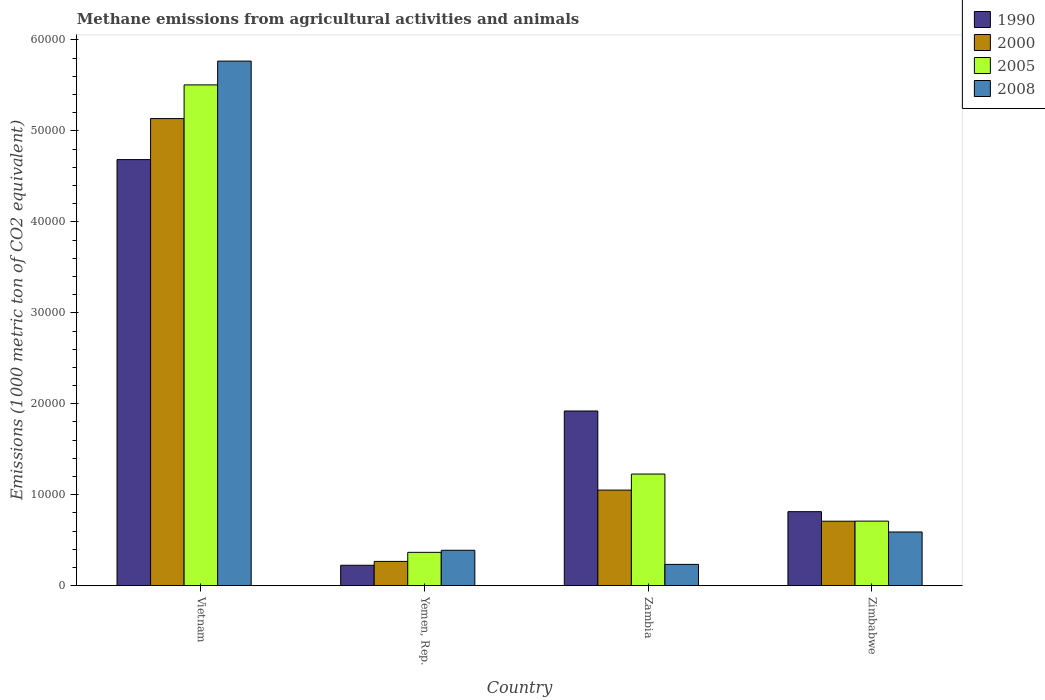How many groups of bars are there?
Make the answer very short. 4. Are the number of bars on each tick of the X-axis equal?
Offer a very short reply. Yes. How many bars are there on the 2nd tick from the right?
Offer a very short reply. 4. What is the label of the 4th group of bars from the left?
Make the answer very short. Zimbabwe. What is the amount of methane emitted in 2005 in Vietnam?
Give a very brief answer. 5.51e+04. Across all countries, what is the maximum amount of methane emitted in 2000?
Offer a terse response. 5.14e+04. Across all countries, what is the minimum amount of methane emitted in 1990?
Give a very brief answer. 2246.7. In which country was the amount of methane emitted in 2008 maximum?
Make the answer very short. Vietnam. In which country was the amount of methane emitted in 1990 minimum?
Offer a very short reply. Yemen, Rep. What is the total amount of methane emitted in 1990 in the graph?
Your response must be concise. 7.64e+04. What is the difference between the amount of methane emitted in 2000 in Vietnam and that in Zimbabwe?
Your answer should be compact. 4.43e+04. What is the difference between the amount of methane emitted in 2000 in Yemen, Rep. and the amount of methane emitted in 1990 in Vietnam?
Provide a succinct answer. -4.42e+04. What is the average amount of methane emitted in 2008 per country?
Give a very brief answer. 1.75e+04. What is the difference between the amount of methane emitted of/in 2000 and amount of methane emitted of/in 2005 in Zimbabwe?
Make the answer very short. -9.1. In how many countries, is the amount of methane emitted in 1990 greater than 12000 1000 metric ton?
Offer a terse response. 2. What is the ratio of the amount of methane emitted in 2000 in Vietnam to that in Zambia?
Your answer should be very brief. 4.89. What is the difference between the highest and the second highest amount of methane emitted in 2005?
Provide a succinct answer. -5176.1. What is the difference between the highest and the lowest amount of methane emitted in 1990?
Offer a very short reply. 4.46e+04. Is it the case that in every country, the sum of the amount of methane emitted in 1990 and amount of methane emitted in 2005 is greater than the sum of amount of methane emitted in 2000 and amount of methane emitted in 2008?
Give a very brief answer. No. What does the 3rd bar from the left in Zimbabwe represents?
Provide a succinct answer. 2005. What does the 2nd bar from the right in Zambia represents?
Ensure brevity in your answer.  2005. How many bars are there?
Your response must be concise. 16. Does the graph contain grids?
Your answer should be very brief. No. Where does the legend appear in the graph?
Provide a succinct answer. Top right. What is the title of the graph?
Your answer should be very brief. Methane emissions from agricultural activities and animals. Does "1975" appear as one of the legend labels in the graph?
Your answer should be very brief. No. What is the label or title of the Y-axis?
Ensure brevity in your answer.  Emissions (1000 metric ton of CO2 equivalent). What is the Emissions (1000 metric ton of CO2 equivalent) in 1990 in Vietnam?
Ensure brevity in your answer.  4.68e+04. What is the Emissions (1000 metric ton of CO2 equivalent) in 2000 in Vietnam?
Give a very brief answer. 5.14e+04. What is the Emissions (1000 metric ton of CO2 equivalent) in 2005 in Vietnam?
Your response must be concise. 5.51e+04. What is the Emissions (1000 metric ton of CO2 equivalent) of 2008 in Vietnam?
Ensure brevity in your answer.  5.77e+04. What is the Emissions (1000 metric ton of CO2 equivalent) of 1990 in Yemen, Rep.?
Provide a short and direct response. 2246.7. What is the Emissions (1000 metric ton of CO2 equivalent) of 2000 in Yemen, Rep.?
Make the answer very short. 2671. What is the Emissions (1000 metric ton of CO2 equivalent) in 2005 in Yemen, Rep.?
Your response must be concise. 3666.5. What is the Emissions (1000 metric ton of CO2 equivalent) in 2008 in Yemen, Rep.?
Your answer should be very brief. 3893.6. What is the Emissions (1000 metric ton of CO2 equivalent) of 1990 in Zambia?
Ensure brevity in your answer.  1.92e+04. What is the Emissions (1000 metric ton of CO2 equivalent) in 2000 in Zambia?
Keep it short and to the point. 1.05e+04. What is the Emissions (1000 metric ton of CO2 equivalent) of 2005 in Zambia?
Provide a short and direct response. 1.23e+04. What is the Emissions (1000 metric ton of CO2 equivalent) in 2008 in Zambia?
Offer a very short reply. 2342.5. What is the Emissions (1000 metric ton of CO2 equivalent) in 1990 in Zimbabwe?
Your answer should be very brief. 8138.9. What is the Emissions (1000 metric ton of CO2 equivalent) of 2000 in Zimbabwe?
Your response must be concise. 7089.3. What is the Emissions (1000 metric ton of CO2 equivalent) of 2005 in Zimbabwe?
Ensure brevity in your answer.  7098.4. What is the Emissions (1000 metric ton of CO2 equivalent) of 2008 in Zimbabwe?
Offer a very short reply. 5904.5. Across all countries, what is the maximum Emissions (1000 metric ton of CO2 equivalent) in 1990?
Provide a succinct answer. 4.68e+04. Across all countries, what is the maximum Emissions (1000 metric ton of CO2 equivalent) of 2000?
Provide a succinct answer. 5.14e+04. Across all countries, what is the maximum Emissions (1000 metric ton of CO2 equivalent) in 2005?
Your answer should be very brief. 5.51e+04. Across all countries, what is the maximum Emissions (1000 metric ton of CO2 equivalent) of 2008?
Make the answer very short. 5.77e+04. Across all countries, what is the minimum Emissions (1000 metric ton of CO2 equivalent) of 1990?
Provide a succinct answer. 2246.7. Across all countries, what is the minimum Emissions (1000 metric ton of CO2 equivalent) of 2000?
Provide a short and direct response. 2671. Across all countries, what is the minimum Emissions (1000 metric ton of CO2 equivalent) in 2005?
Offer a very short reply. 3666.5. Across all countries, what is the minimum Emissions (1000 metric ton of CO2 equivalent) of 2008?
Provide a succinct answer. 2342.5. What is the total Emissions (1000 metric ton of CO2 equivalent) of 1990 in the graph?
Provide a succinct answer. 7.64e+04. What is the total Emissions (1000 metric ton of CO2 equivalent) in 2000 in the graph?
Keep it short and to the point. 7.16e+04. What is the total Emissions (1000 metric ton of CO2 equivalent) in 2005 in the graph?
Your response must be concise. 7.81e+04. What is the total Emissions (1000 metric ton of CO2 equivalent) in 2008 in the graph?
Your answer should be very brief. 6.98e+04. What is the difference between the Emissions (1000 metric ton of CO2 equivalent) of 1990 in Vietnam and that in Yemen, Rep.?
Make the answer very short. 4.46e+04. What is the difference between the Emissions (1000 metric ton of CO2 equivalent) of 2000 in Vietnam and that in Yemen, Rep.?
Keep it short and to the point. 4.87e+04. What is the difference between the Emissions (1000 metric ton of CO2 equivalent) in 2005 in Vietnam and that in Yemen, Rep.?
Make the answer very short. 5.14e+04. What is the difference between the Emissions (1000 metric ton of CO2 equivalent) of 2008 in Vietnam and that in Yemen, Rep.?
Ensure brevity in your answer.  5.38e+04. What is the difference between the Emissions (1000 metric ton of CO2 equivalent) in 1990 in Vietnam and that in Zambia?
Make the answer very short. 2.76e+04. What is the difference between the Emissions (1000 metric ton of CO2 equivalent) of 2000 in Vietnam and that in Zambia?
Provide a short and direct response. 4.08e+04. What is the difference between the Emissions (1000 metric ton of CO2 equivalent) of 2005 in Vietnam and that in Zambia?
Your answer should be compact. 4.28e+04. What is the difference between the Emissions (1000 metric ton of CO2 equivalent) of 2008 in Vietnam and that in Zambia?
Ensure brevity in your answer.  5.53e+04. What is the difference between the Emissions (1000 metric ton of CO2 equivalent) in 1990 in Vietnam and that in Zimbabwe?
Your response must be concise. 3.87e+04. What is the difference between the Emissions (1000 metric ton of CO2 equivalent) in 2000 in Vietnam and that in Zimbabwe?
Make the answer very short. 4.43e+04. What is the difference between the Emissions (1000 metric ton of CO2 equivalent) in 2005 in Vietnam and that in Zimbabwe?
Keep it short and to the point. 4.80e+04. What is the difference between the Emissions (1000 metric ton of CO2 equivalent) in 2008 in Vietnam and that in Zimbabwe?
Your answer should be compact. 5.18e+04. What is the difference between the Emissions (1000 metric ton of CO2 equivalent) of 1990 in Yemen, Rep. and that in Zambia?
Provide a succinct answer. -1.70e+04. What is the difference between the Emissions (1000 metric ton of CO2 equivalent) of 2000 in Yemen, Rep. and that in Zambia?
Offer a terse response. -7837.9. What is the difference between the Emissions (1000 metric ton of CO2 equivalent) in 2005 in Yemen, Rep. and that in Zambia?
Your response must be concise. -8608. What is the difference between the Emissions (1000 metric ton of CO2 equivalent) of 2008 in Yemen, Rep. and that in Zambia?
Your response must be concise. 1551.1. What is the difference between the Emissions (1000 metric ton of CO2 equivalent) in 1990 in Yemen, Rep. and that in Zimbabwe?
Provide a succinct answer. -5892.2. What is the difference between the Emissions (1000 metric ton of CO2 equivalent) of 2000 in Yemen, Rep. and that in Zimbabwe?
Keep it short and to the point. -4418.3. What is the difference between the Emissions (1000 metric ton of CO2 equivalent) of 2005 in Yemen, Rep. and that in Zimbabwe?
Ensure brevity in your answer.  -3431.9. What is the difference between the Emissions (1000 metric ton of CO2 equivalent) of 2008 in Yemen, Rep. and that in Zimbabwe?
Provide a short and direct response. -2010.9. What is the difference between the Emissions (1000 metric ton of CO2 equivalent) of 1990 in Zambia and that in Zimbabwe?
Ensure brevity in your answer.  1.11e+04. What is the difference between the Emissions (1000 metric ton of CO2 equivalent) in 2000 in Zambia and that in Zimbabwe?
Your answer should be compact. 3419.6. What is the difference between the Emissions (1000 metric ton of CO2 equivalent) of 2005 in Zambia and that in Zimbabwe?
Make the answer very short. 5176.1. What is the difference between the Emissions (1000 metric ton of CO2 equivalent) in 2008 in Zambia and that in Zimbabwe?
Keep it short and to the point. -3562. What is the difference between the Emissions (1000 metric ton of CO2 equivalent) of 1990 in Vietnam and the Emissions (1000 metric ton of CO2 equivalent) of 2000 in Yemen, Rep.?
Make the answer very short. 4.42e+04. What is the difference between the Emissions (1000 metric ton of CO2 equivalent) of 1990 in Vietnam and the Emissions (1000 metric ton of CO2 equivalent) of 2005 in Yemen, Rep.?
Your answer should be compact. 4.32e+04. What is the difference between the Emissions (1000 metric ton of CO2 equivalent) in 1990 in Vietnam and the Emissions (1000 metric ton of CO2 equivalent) in 2008 in Yemen, Rep.?
Keep it short and to the point. 4.30e+04. What is the difference between the Emissions (1000 metric ton of CO2 equivalent) in 2000 in Vietnam and the Emissions (1000 metric ton of CO2 equivalent) in 2005 in Yemen, Rep.?
Provide a short and direct response. 4.77e+04. What is the difference between the Emissions (1000 metric ton of CO2 equivalent) of 2000 in Vietnam and the Emissions (1000 metric ton of CO2 equivalent) of 2008 in Yemen, Rep.?
Give a very brief answer. 4.75e+04. What is the difference between the Emissions (1000 metric ton of CO2 equivalent) of 2005 in Vietnam and the Emissions (1000 metric ton of CO2 equivalent) of 2008 in Yemen, Rep.?
Your answer should be compact. 5.12e+04. What is the difference between the Emissions (1000 metric ton of CO2 equivalent) in 1990 in Vietnam and the Emissions (1000 metric ton of CO2 equivalent) in 2000 in Zambia?
Your answer should be compact. 3.63e+04. What is the difference between the Emissions (1000 metric ton of CO2 equivalent) of 1990 in Vietnam and the Emissions (1000 metric ton of CO2 equivalent) of 2005 in Zambia?
Keep it short and to the point. 3.46e+04. What is the difference between the Emissions (1000 metric ton of CO2 equivalent) of 1990 in Vietnam and the Emissions (1000 metric ton of CO2 equivalent) of 2008 in Zambia?
Your answer should be very brief. 4.45e+04. What is the difference between the Emissions (1000 metric ton of CO2 equivalent) in 2000 in Vietnam and the Emissions (1000 metric ton of CO2 equivalent) in 2005 in Zambia?
Give a very brief answer. 3.91e+04. What is the difference between the Emissions (1000 metric ton of CO2 equivalent) in 2000 in Vietnam and the Emissions (1000 metric ton of CO2 equivalent) in 2008 in Zambia?
Offer a very short reply. 4.90e+04. What is the difference between the Emissions (1000 metric ton of CO2 equivalent) in 2005 in Vietnam and the Emissions (1000 metric ton of CO2 equivalent) in 2008 in Zambia?
Provide a succinct answer. 5.27e+04. What is the difference between the Emissions (1000 metric ton of CO2 equivalent) of 1990 in Vietnam and the Emissions (1000 metric ton of CO2 equivalent) of 2000 in Zimbabwe?
Your answer should be compact. 3.98e+04. What is the difference between the Emissions (1000 metric ton of CO2 equivalent) in 1990 in Vietnam and the Emissions (1000 metric ton of CO2 equivalent) in 2005 in Zimbabwe?
Your response must be concise. 3.97e+04. What is the difference between the Emissions (1000 metric ton of CO2 equivalent) of 1990 in Vietnam and the Emissions (1000 metric ton of CO2 equivalent) of 2008 in Zimbabwe?
Ensure brevity in your answer.  4.09e+04. What is the difference between the Emissions (1000 metric ton of CO2 equivalent) in 2000 in Vietnam and the Emissions (1000 metric ton of CO2 equivalent) in 2005 in Zimbabwe?
Your answer should be very brief. 4.43e+04. What is the difference between the Emissions (1000 metric ton of CO2 equivalent) in 2000 in Vietnam and the Emissions (1000 metric ton of CO2 equivalent) in 2008 in Zimbabwe?
Give a very brief answer. 4.55e+04. What is the difference between the Emissions (1000 metric ton of CO2 equivalent) of 2005 in Vietnam and the Emissions (1000 metric ton of CO2 equivalent) of 2008 in Zimbabwe?
Keep it short and to the point. 4.92e+04. What is the difference between the Emissions (1000 metric ton of CO2 equivalent) in 1990 in Yemen, Rep. and the Emissions (1000 metric ton of CO2 equivalent) in 2000 in Zambia?
Keep it short and to the point. -8262.2. What is the difference between the Emissions (1000 metric ton of CO2 equivalent) in 1990 in Yemen, Rep. and the Emissions (1000 metric ton of CO2 equivalent) in 2005 in Zambia?
Offer a terse response. -1.00e+04. What is the difference between the Emissions (1000 metric ton of CO2 equivalent) in 1990 in Yemen, Rep. and the Emissions (1000 metric ton of CO2 equivalent) in 2008 in Zambia?
Offer a terse response. -95.8. What is the difference between the Emissions (1000 metric ton of CO2 equivalent) of 2000 in Yemen, Rep. and the Emissions (1000 metric ton of CO2 equivalent) of 2005 in Zambia?
Offer a terse response. -9603.5. What is the difference between the Emissions (1000 metric ton of CO2 equivalent) in 2000 in Yemen, Rep. and the Emissions (1000 metric ton of CO2 equivalent) in 2008 in Zambia?
Give a very brief answer. 328.5. What is the difference between the Emissions (1000 metric ton of CO2 equivalent) of 2005 in Yemen, Rep. and the Emissions (1000 metric ton of CO2 equivalent) of 2008 in Zambia?
Make the answer very short. 1324. What is the difference between the Emissions (1000 metric ton of CO2 equivalent) in 1990 in Yemen, Rep. and the Emissions (1000 metric ton of CO2 equivalent) in 2000 in Zimbabwe?
Offer a terse response. -4842.6. What is the difference between the Emissions (1000 metric ton of CO2 equivalent) in 1990 in Yemen, Rep. and the Emissions (1000 metric ton of CO2 equivalent) in 2005 in Zimbabwe?
Provide a short and direct response. -4851.7. What is the difference between the Emissions (1000 metric ton of CO2 equivalent) in 1990 in Yemen, Rep. and the Emissions (1000 metric ton of CO2 equivalent) in 2008 in Zimbabwe?
Ensure brevity in your answer.  -3657.8. What is the difference between the Emissions (1000 metric ton of CO2 equivalent) in 2000 in Yemen, Rep. and the Emissions (1000 metric ton of CO2 equivalent) in 2005 in Zimbabwe?
Give a very brief answer. -4427.4. What is the difference between the Emissions (1000 metric ton of CO2 equivalent) in 2000 in Yemen, Rep. and the Emissions (1000 metric ton of CO2 equivalent) in 2008 in Zimbabwe?
Provide a short and direct response. -3233.5. What is the difference between the Emissions (1000 metric ton of CO2 equivalent) of 2005 in Yemen, Rep. and the Emissions (1000 metric ton of CO2 equivalent) of 2008 in Zimbabwe?
Your answer should be very brief. -2238. What is the difference between the Emissions (1000 metric ton of CO2 equivalent) in 1990 in Zambia and the Emissions (1000 metric ton of CO2 equivalent) in 2000 in Zimbabwe?
Your answer should be compact. 1.21e+04. What is the difference between the Emissions (1000 metric ton of CO2 equivalent) of 1990 in Zambia and the Emissions (1000 metric ton of CO2 equivalent) of 2005 in Zimbabwe?
Your answer should be very brief. 1.21e+04. What is the difference between the Emissions (1000 metric ton of CO2 equivalent) of 1990 in Zambia and the Emissions (1000 metric ton of CO2 equivalent) of 2008 in Zimbabwe?
Give a very brief answer. 1.33e+04. What is the difference between the Emissions (1000 metric ton of CO2 equivalent) of 2000 in Zambia and the Emissions (1000 metric ton of CO2 equivalent) of 2005 in Zimbabwe?
Provide a short and direct response. 3410.5. What is the difference between the Emissions (1000 metric ton of CO2 equivalent) in 2000 in Zambia and the Emissions (1000 metric ton of CO2 equivalent) in 2008 in Zimbabwe?
Provide a short and direct response. 4604.4. What is the difference between the Emissions (1000 metric ton of CO2 equivalent) in 2005 in Zambia and the Emissions (1000 metric ton of CO2 equivalent) in 2008 in Zimbabwe?
Your answer should be very brief. 6370. What is the average Emissions (1000 metric ton of CO2 equivalent) of 1990 per country?
Your answer should be very brief. 1.91e+04. What is the average Emissions (1000 metric ton of CO2 equivalent) of 2000 per country?
Your answer should be compact. 1.79e+04. What is the average Emissions (1000 metric ton of CO2 equivalent) of 2005 per country?
Offer a very short reply. 1.95e+04. What is the average Emissions (1000 metric ton of CO2 equivalent) in 2008 per country?
Keep it short and to the point. 1.75e+04. What is the difference between the Emissions (1000 metric ton of CO2 equivalent) in 1990 and Emissions (1000 metric ton of CO2 equivalent) in 2000 in Vietnam?
Offer a terse response. -4511. What is the difference between the Emissions (1000 metric ton of CO2 equivalent) in 1990 and Emissions (1000 metric ton of CO2 equivalent) in 2005 in Vietnam?
Your response must be concise. -8213.9. What is the difference between the Emissions (1000 metric ton of CO2 equivalent) of 1990 and Emissions (1000 metric ton of CO2 equivalent) of 2008 in Vietnam?
Make the answer very short. -1.08e+04. What is the difference between the Emissions (1000 metric ton of CO2 equivalent) of 2000 and Emissions (1000 metric ton of CO2 equivalent) of 2005 in Vietnam?
Your answer should be very brief. -3702.9. What is the difference between the Emissions (1000 metric ton of CO2 equivalent) in 2000 and Emissions (1000 metric ton of CO2 equivalent) in 2008 in Vietnam?
Provide a succinct answer. -6319.4. What is the difference between the Emissions (1000 metric ton of CO2 equivalent) in 2005 and Emissions (1000 metric ton of CO2 equivalent) in 2008 in Vietnam?
Keep it short and to the point. -2616.5. What is the difference between the Emissions (1000 metric ton of CO2 equivalent) of 1990 and Emissions (1000 metric ton of CO2 equivalent) of 2000 in Yemen, Rep.?
Ensure brevity in your answer.  -424.3. What is the difference between the Emissions (1000 metric ton of CO2 equivalent) of 1990 and Emissions (1000 metric ton of CO2 equivalent) of 2005 in Yemen, Rep.?
Your answer should be very brief. -1419.8. What is the difference between the Emissions (1000 metric ton of CO2 equivalent) of 1990 and Emissions (1000 metric ton of CO2 equivalent) of 2008 in Yemen, Rep.?
Provide a succinct answer. -1646.9. What is the difference between the Emissions (1000 metric ton of CO2 equivalent) of 2000 and Emissions (1000 metric ton of CO2 equivalent) of 2005 in Yemen, Rep.?
Provide a succinct answer. -995.5. What is the difference between the Emissions (1000 metric ton of CO2 equivalent) of 2000 and Emissions (1000 metric ton of CO2 equivalent) of 2008 in Yemen, Rep.?
Offer a terse response. -1222.6. What is the difference between the Emissions (1000 metric ton of CO2 equivalent) in 2005 and Emissions (1000 metric ton of CO2 equivalent) in 2008 in Yemen, Rep.?
Provide a succinct answer. -227.1. What is the difference between the Emissions (1000 metric ton of CO2 equivalent) in 1990 and Emissions (1000 metric ton of CO2 equivalent) in 2000 in Zambia?
Offer a terse response. 8698.2. What is the difference between the Emissions (1000 metric ton of CO2 equivalent) in 1990 and Emissions (1000 metric ton of CO2 equivalent) in 2005 in Zambia?
Keep it short and to the point. 6932.6. What is the difference between the Emissions (1000 metric ton of CO2 equivalent) in 1990 and Emissions (1000 metric ton of CO2 equivalent) in 2008 in Zambia?
Provide a succinct answer. 1.69e+04. What is the difference between the Emissions (1000 metric ton of CO2 equivalent) of 2000 and Emissions (1000 metric ton of CO2 equivalent) of 2005 in Zambia?
Offer a terse response. -1765.6. What is the difference between the Emissions (1000 metric ton of CO2 equivalent) in 2000 and Emissions (1000 metric ton of CO2 equivalent) in 2008 in Zambia?
Ensure brevity in your answer.  8166.4. What is the difference between the Emissions (1000 metric ton of CO2 equivalent) in 2005 and Emissions (1000 metric ton of CO2 equivalent) in 2008 in Zambia?
Keep it short and to the point. 9932. What is the difference between the Emissions (1000 metric ton of CO2 equivalent) of 1990 and Emissions (1000 metric ton of CO2 equivalent) of 2000 in Zimbabwe?
Offer a very short reply. 1049.6. What is the difference between the Emissions (1000 metric ton of CO2 equivalent) of 1990 and Emissions (1000 metric ton of CO2 equivalent) of 2005 in Zimbabwe?
Offer a terse response. 1040.5. What is the difference between the Emissions (1000 metric ton of CO2 equivalent) of 1990 and Emissions (1000 metric ton of CO2 equivalent) of 2008 in Zimbabwe?
Offer a terse response. 2234.4. What is the difference between the Emissions (1000 metric ton of CO2 equivalent) in 2000 and Emissions (1000 metric ton of CO2 equivalent) in 2008 in Zimbabwe?
Offer a terse response. 1184.8. What is the difference between the Emissions (1000 metric ton of CO2 equivalent) of 2005 and Emissions (1000 metric ton of CO2 equivalent) of 2008 in Zimbabwe?
Provide a succinct answer. 1193.9. What is the ratio of the Emissions (1000 metric ton of CO2 equivalent) in 1990 in Vietnam to that in Yemen, Rep.?
Ensure brevity in your answer.  20.85. What is the ratio of the Emissions (1000 metric ton of CO2 equivalent) of 2000 in Vietnam to that in Yemen, Rep.?
Your answer should be very brief. 19.23. What is the ratio of the Emissions (1000 metric ton of CO2 equivalent) of 2005 in Vietnam to that in Yemen, Rep.?
Keep it short and to the point. 15.02. What is the ratio of the Emissions (1000 metric ton of CO2 equivalent) in 2008 in Vietnam to that in Yemen, Rep.?
Keep it short and to the point. 14.81. What is the ratio of the Emissions (1000 metric ton of CO2 equivalent) of 1990 in Vietnam to that in Zambia?
Offer a terse response. 2.44. What is the ratio of the Emissions (1000 metric ton of CO2 equivalent) of 2000 in Vietnam to that in Zambia?
Your answer should be compact. 4.89. What is the ratio of the Emissions (1000 metric ton of CO2 equivalent) of 2005 in Vietnam to that in Zambia?
Keep it short and to the point. 4.49. What is the ratio of the Emissions (1000 metric ton of CO2 equivalent) of 2008 in Vietnam to that in Zambia?
Provide a short and direct response. 24.62. What is the ratio of the Emissions (1000 metric ton of CO2 equivalent) in 1990 in Vietnam to that in Zimbabwe?
Provide a short and direct response. 5.76. What is the ratio of the Emissions (1000 metric ton of CO2 equivalent) in 2000 in Vietnam to that in Zimbabwe?
Offer a very short reply. 7.24. What is the ratio of the Emissions (1000 metric ton of CO2 equivalent) in 2005 in Vietnam to that in Zimbabwe?
Give a very brief answer. 7.76. What is the ratio of the Emissions (1000 metric ton of CO2 equivalent) of 2008 in Vietnam to that in Zimbabwe?
Offer a very short reply. 9.77. What is the ratio of the Emissions (1000 metric ton of CO2 equivalent) in 1990 in Yemen, Rep. to that in Zambia?
Your response must be concise. 0.12. What is the ratio of the Emissions (1000 metric ton of CO2 equivalent) of 2000 in Yemen, Rep. to that in Zambia?
Keep it short and to the point. 0.25. What is the ratio of the Emissions (1000 metric ton of CO2 equivalent) in 2005 in Yemen, Rep. to that in Zambia?
Your response must be concise. 0.3. What is the ratio of the Emissions (1000 metric ton of CO2 equivalent) in 2008 in Yemen, Rep. to that in Zambia?
Offer a very short reply. 1.66. What is the ratio of the Emissions (1000 metric ton of CO2 equivalent) in 1990 in Yemen, Rep. to that in Zimbabwe?
Provide a succinct answer. 0.28. What is the ratio of the Emissions (1000 metric ton of CO2 equivalent) in 2000 in Yemen, Rep. to that in Zimbabwe?
Your answer should be very brief. 0.38. What is the ratio of the Emissions (1000 metric ton of CO2 equivalent) in 2005 in Yemen, Rep. to that in Zimbabwe?
Keep it short and to the point. 0.52. What is the ratio of the Emissions (1000 metric ton of CO2 equivalent) of 2008 in Yemen, Rep. to that in Zimbabwe?
Offer a terse response. 0.66. What is the ratio of the Emissions (1000 metric ton of CO2 equivalent) of 1990 in Zambia to that in Zimbabwe?
Keep it short and to the point. 2.36. What is the ratio of the Emissions (1000 metric ton of CO2 equivalent) in 2000 in Zambia to that in Zimbabwe?
Ensure brevity in your answer.  1.48. What is the ratio of the Emissions (1000 metric ton of CO2 equivalent) in 2005 in Zambia to that in Zimbabwe?
Your answer should be very brief. 1.73. What is the ratio of the Emissions (1000 metric ton of CO2 equivalent) in 2008 in Zambia to that in Zimbabwe?
Keep it short and to the point. 0.4. What is the difference between the highest and the second highest Emissions (1000 metric ton of CO2 equivalent) of 1990?
Keep it short and to the point. 2.76e+04. What is the difference between the highest and the second highest Emissions (1000 metric ton of CO2 equivalent) of 2000?
Your response must be concise. 4.08e+04. What is the difference between the highest and the second highest Emissions (1000 metric ton of CO2 equivalent) of 2005?
Offer a very short reply. 4.28e+04. What is the difference between the highest and the second highest Emissions (1000 metric ton of CO2 equivalent) of 2008?
Make the answer very short. 5.18e+04. What is the difference between the highest and the lowest Emissions (1000 metric ton of CO2 equivalent) of 1990?
Keep it short and to the point. 4.46e+04. What is the difference between the highest and the lowest Emissions (1000 metric ton of CO2 equivalent) of 2000?
Make the answer very short. 4.87e+04. What is the difference between the highest and the lowest Emissions (1000 metric ton of CO2 equivalent) in 2005?
Offer a terse response. 5.14e+04. What is the difference between the highest and the lowest Emissions (1000 metric ton of CO2 equivalent) in 2008?
Keep it short and to the point. 5.53e+04. 